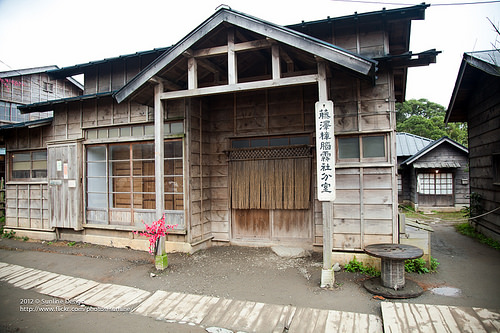<image>
Can you confirm if the table is in front of the board? No. The table is not in front of the board. The spatial positioning shows a different relationship between these objects. 